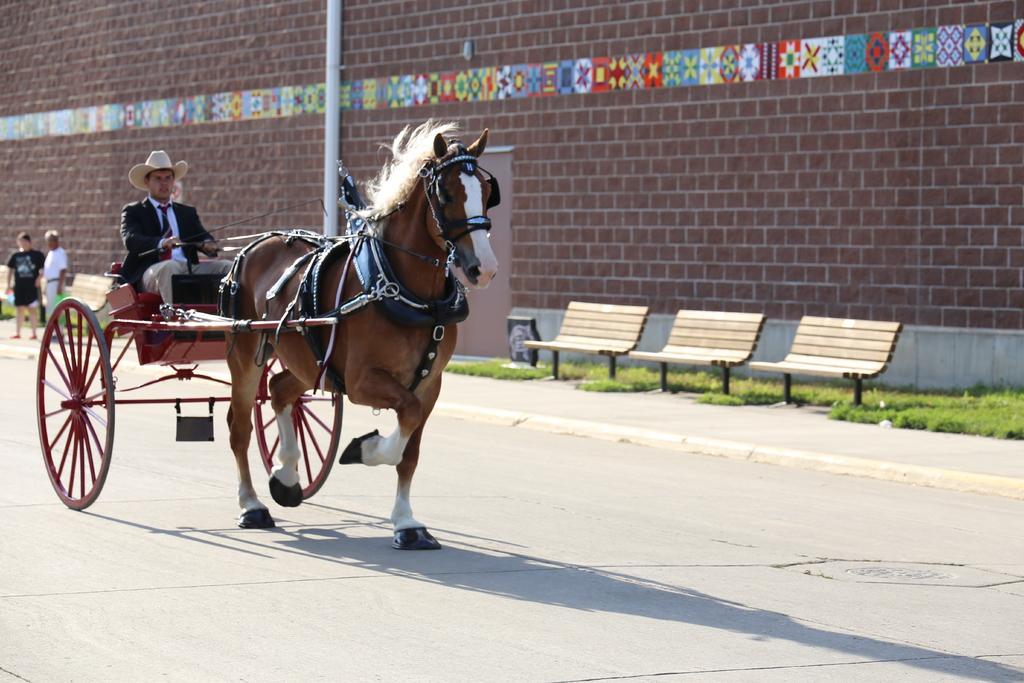Could you give a brief overview of what you see in this image? A man is riding a horse kart wearing a hat and suit on a road. There are three benches on the footpath. There is large wall with a pole in the background. There are two people in the background. 